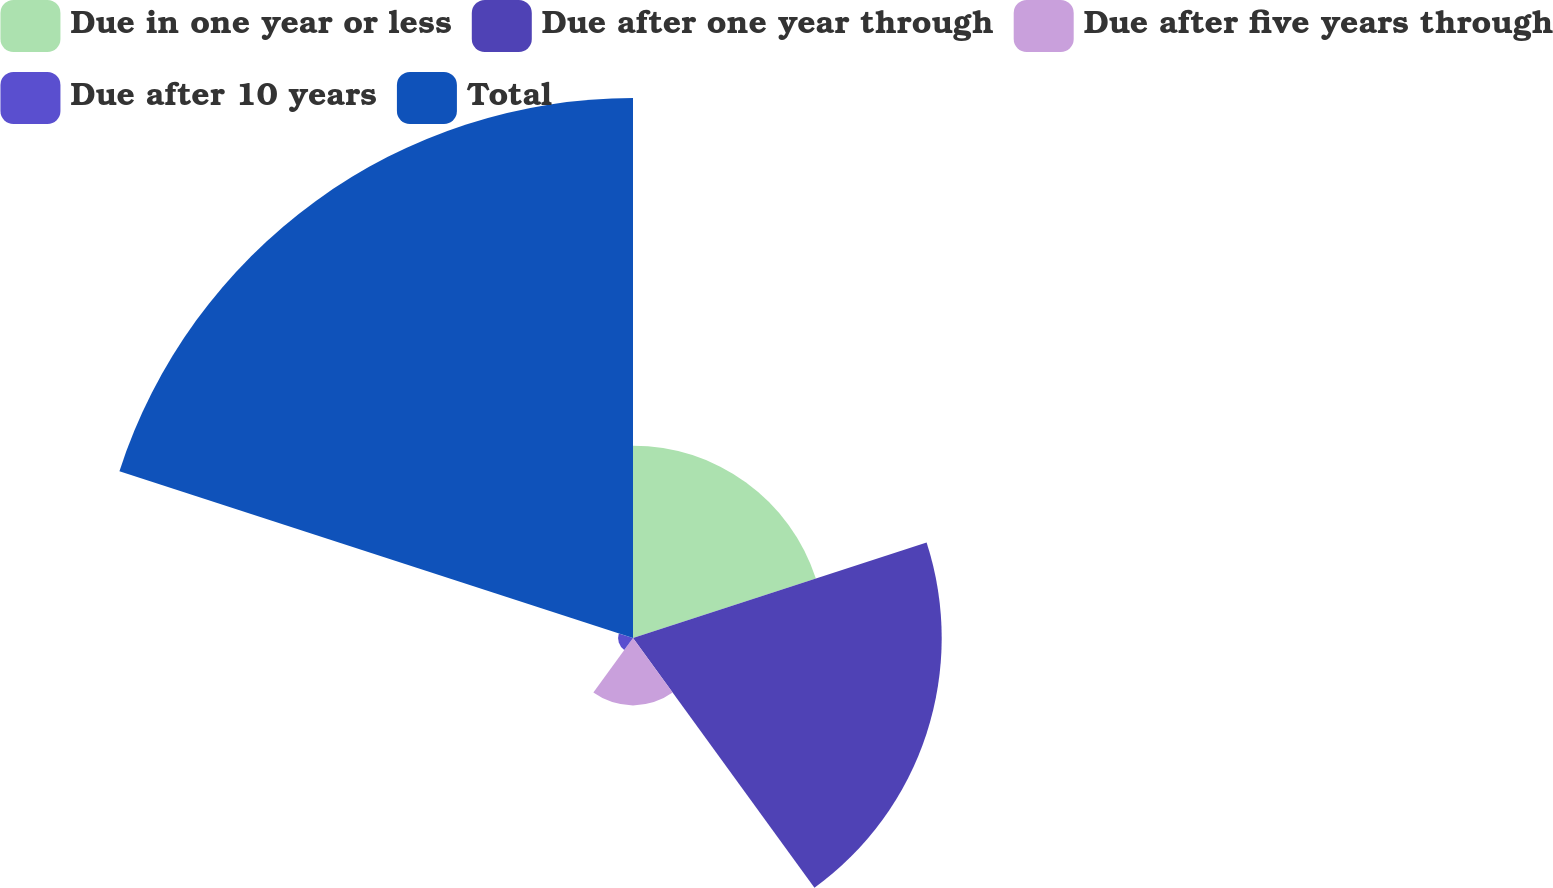Convert chart to OTSL. <chart><loc_0><loc_0><loc_500><loc_500><pie_chart><fcel>Due in one year or less<fcel>Due after one year through<fcel>Due after five years through<fcel>Due after 10 years<fcel>Total<nl><fcel>17.12%<fcel>27.48%<fcel>6.0%<fcel>1.33%<fcel>48.07%<nl></chart> 